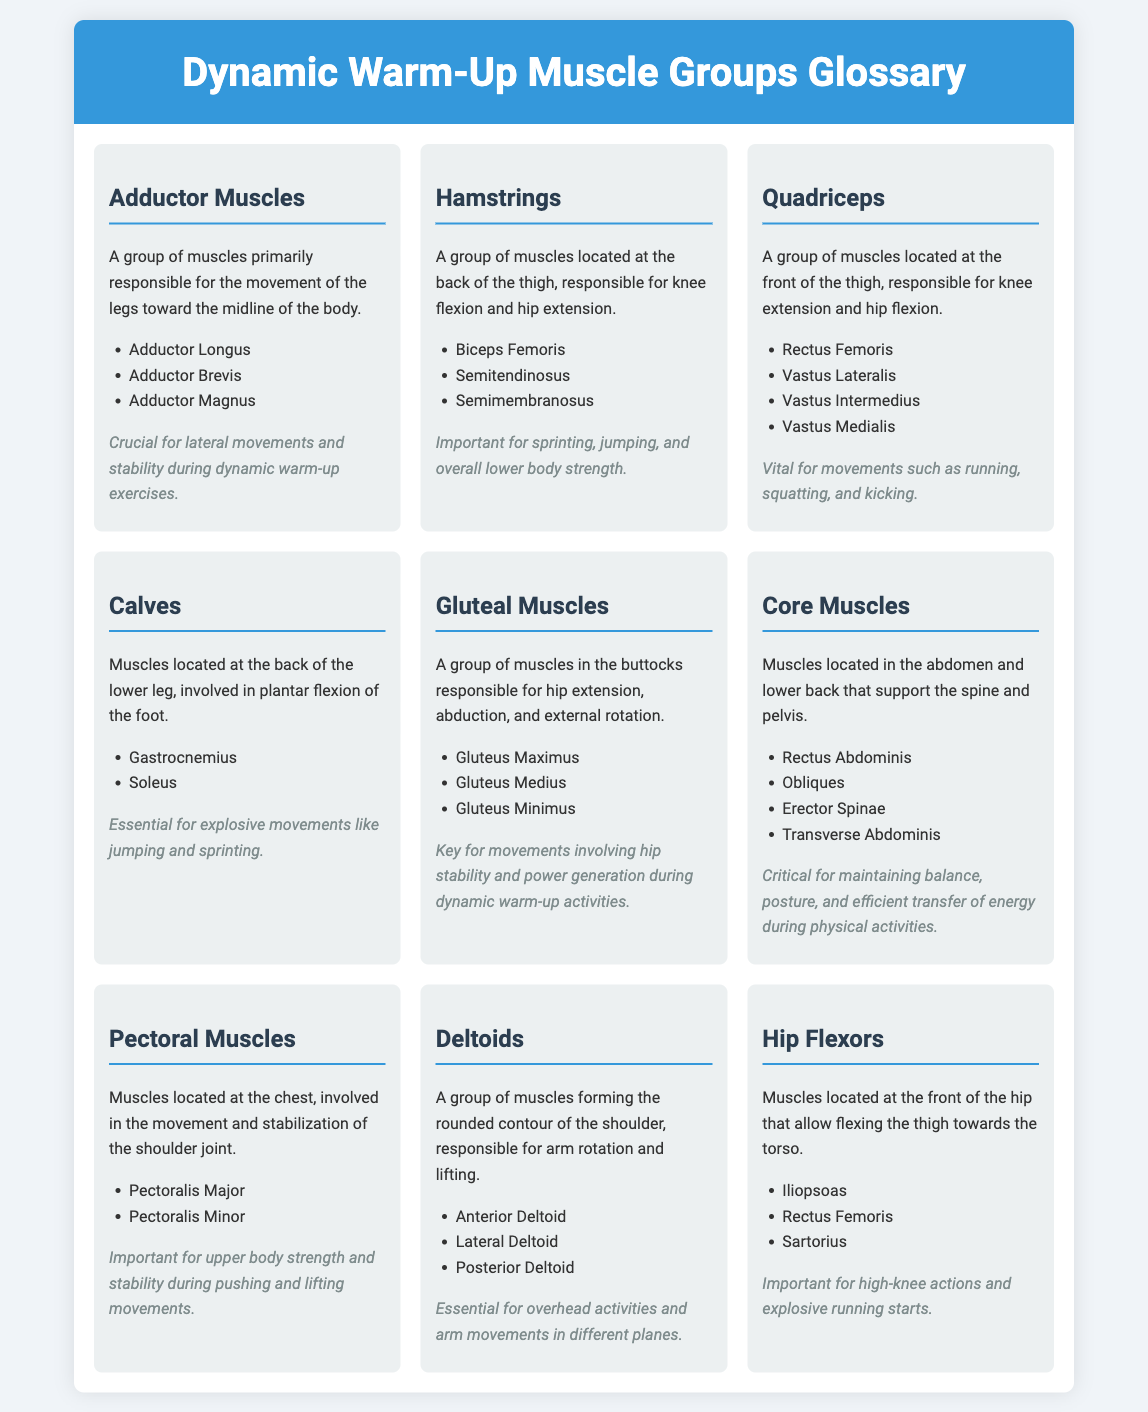What are the three main adductor muscles? The adductor muscles include Adductor Longus, Adductor Brevis, and Adductor Magnus, which are listed under the Adductor Muscles section.
Answer: Adductor Longus, Adductor Brevis, Adductor Magnus What is the primary function of the hamstrings? The hamstrings are responsible for knee flexion and hip extension as stated in the section about Hamstrings.
Answer: Knee flexion and hip extension What muscles make up the quadriceps group? The quadriceps consist of Rectus Femoris, Vastus Lateralis, Vastus Intermedius, and Vastus Medialis, as detailed in the Quadriceps section.
Answer: Rectus Femoris, Vastus Lateralis, Vastus Intermedius, Vastus Medialis Which muscle group is essential for explosive movements like jumping? The muscle group involved in explosive movements like jumping is the Calves, specifically the Gastrocnemius and Soleus.
Answer: Calves How do core muscles contribute to physical activities? Core muscles are critical for maintaining balance, posture, and efficient transfer of energy, which is explained in the Core Muscles section.
Answer: Balance, posture, efficient energy transfer What role do gluteal muscles play during dynamic warm-ups? Gluteal muscles are key for movements involving hip stability and power generation during dynamic warm-up activities.
Answer: Hip stability and power generation How many types of deltoids are mentioned? The document mentions three types of deltoids: Anterior Deltoid, Lateral Deltoid, and Posterior Deltoid.
Answer: Three types Which muscle is part of the hip flexors group? The Iliopsoas is one of the muscles listed in the Hip Flexors group.
Answer: Iliopsoas 